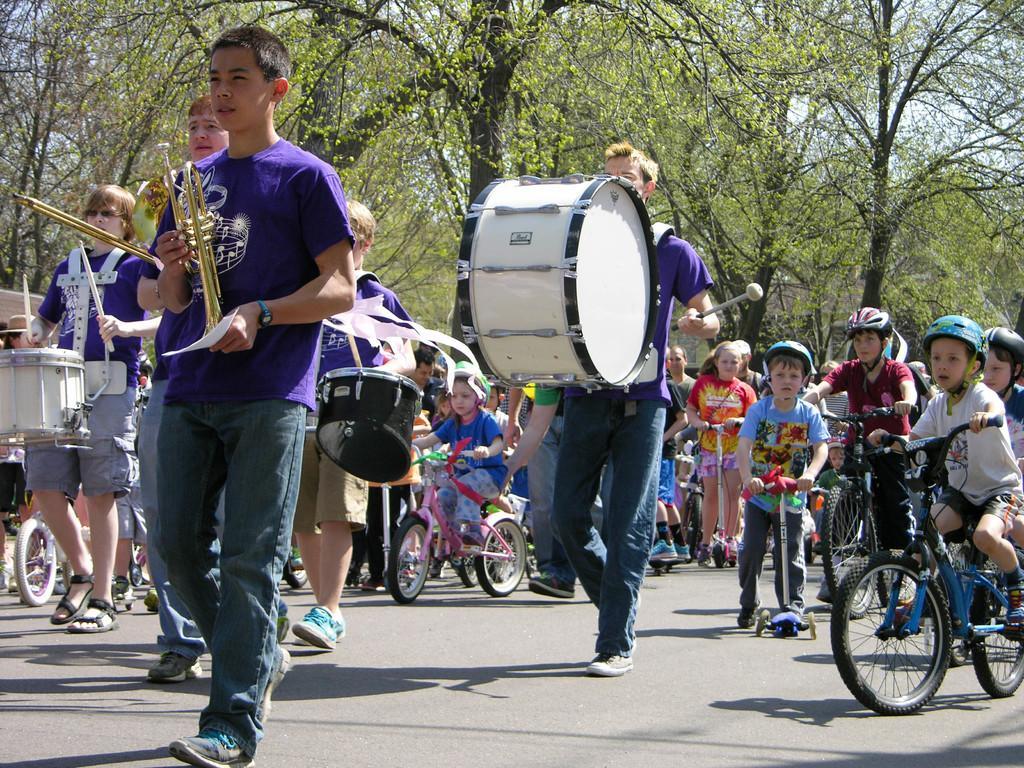Could you give a brief overview of what you see in this image? In the picture we can see many children walking and holding musical instrument in their hand. Some of them are riding bicycle. There are trees around and sky above. 